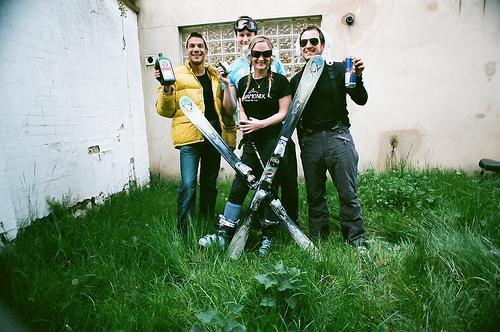How many people are wearing light blue or yellow?
Give a very brief answer. 2. 